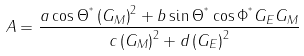Convert formula to latex. <formula><loc_0><loc_0><loc_500><loc_500>A = \frac { a \cos \Theta ^ { ^ { * } } \left ( G _ { M } \right ) ^ { 2 } + b \sin \Theta ^ { ^ { * } } \cos \Phi ^ { ^ { * } } G _ { E } G _ { M } } { c \left ( G _ { M } \right ) ^ { 2 } + d \left ( G _ { E } \right ) ^ { 2 } }</formula> 